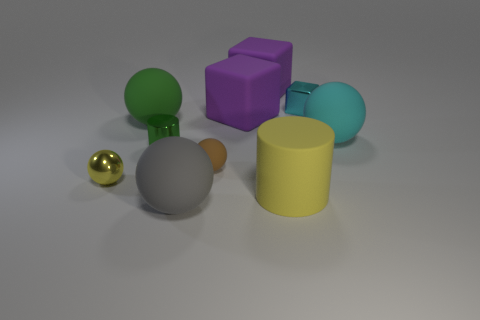Are there any small shiny spheres that have the same color as the large rubber cylinder?
Provide a short and direct response. Yes. There is a object that is the same color as the large matte cylinder; what size is it?
Your response must be concise. Small. What color is the tiny shiny thing right of the tiny ball that is right of the yellow sphere?
Offer a terse response. Cyan. How many other things are the same color as the small rubber ball?
Offer a very short reply. 0. What is the size of the metal cylinder?
Give a very brief answer. Small. Are there more big purple blocks that are behind the big gray rubber ball than small brown matte balls left of the small cylinder?
Provide a succinct answer. Yes. There is a small sphere to the right of the tiny cylinder; what number of small metal things are right of it?
Keep it short and to the point. 1. There is a small metal object that is in front of the brown thing; is it the same shape as the green matte thing?
Your response must be concise. Yes. There is a yellow object that is the same shape as the small brown matte object; what is its material?
Provide a succinct answer. Metal. What number of red shiny things are the same size as the cyan ball?
Ensure brevity in your answer.  0. 